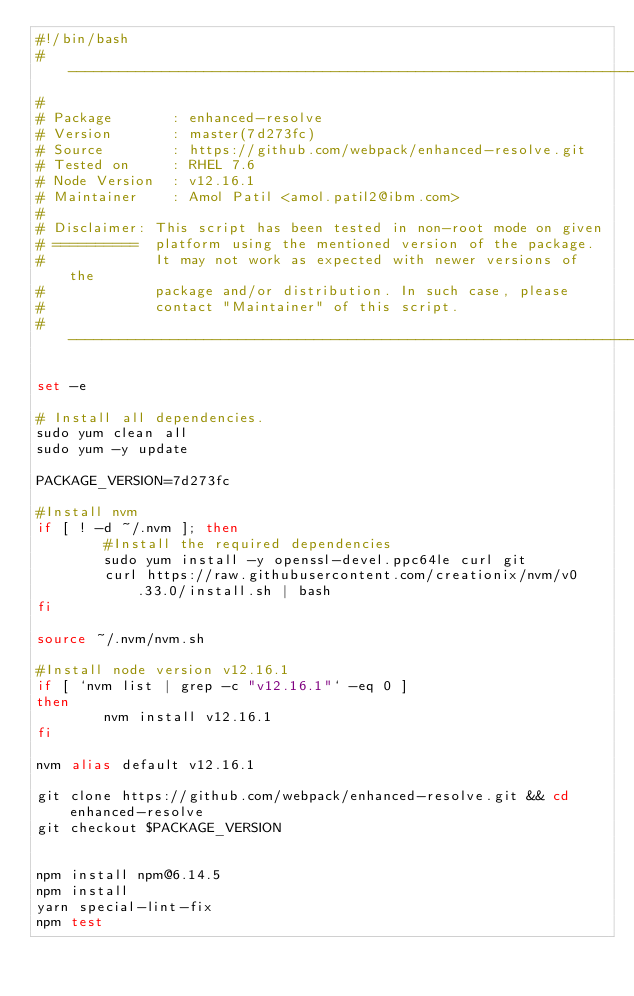Convert code to text. <code><loc_0><loc_0><loc_500><loc_500><_Bash_>#!/bin/bash
# ----------------------------------------------------------------------------
#
# Package       : enhanced-resolve
# Version       : master(7d273fc)
# Source        : https://github.com/webpack/enhanced-resolve.git 
# Tested on     : RHEL 7.6
# Node Version  : v12.16.1
# Maintainer    : Amol Patil <amol.patil2@ibm.com>
#
# Disclaimer: This script has been tested in non-root mode on given
# ==========  platform using the mentioned version of the package.
#             It may not work as expected with newer versions of the
#             package and/or distribution. In such case, please
#             contact "Maintainer" of this script.
# ----------------------------------------------------------------------------

set -e

# Install all dependencies.
sudo yum clean all
sudo yum -y update

PACKAGE_VERSION=7d273fc

#Install nvm
if [ ! -d ~/.nvm ]; then
        #Install the required dependencies
        sudo yum install -y openssl-devel.ppc64le curl git 
        curl https://raw.githubusercontent.com/creationix/nvm/v0.33.0/install.sh | bash
fi

source ~/.nvm/nvm.sh

#Install node version v12.16.1
if [ `nvm list | grep -c "v12.16.1"` -eq 0 ]
then
        nvm install v12.16.1
fi

nvm alias default v12.16.1

git clone https://github.com/webpack/enhanced-resolve.git && cd enhanced-resolve
git checkout $PACKAGE_VERSION


npm install npm@6.14.5
npm install
yarn special-lint-fix
npm test

</code> 